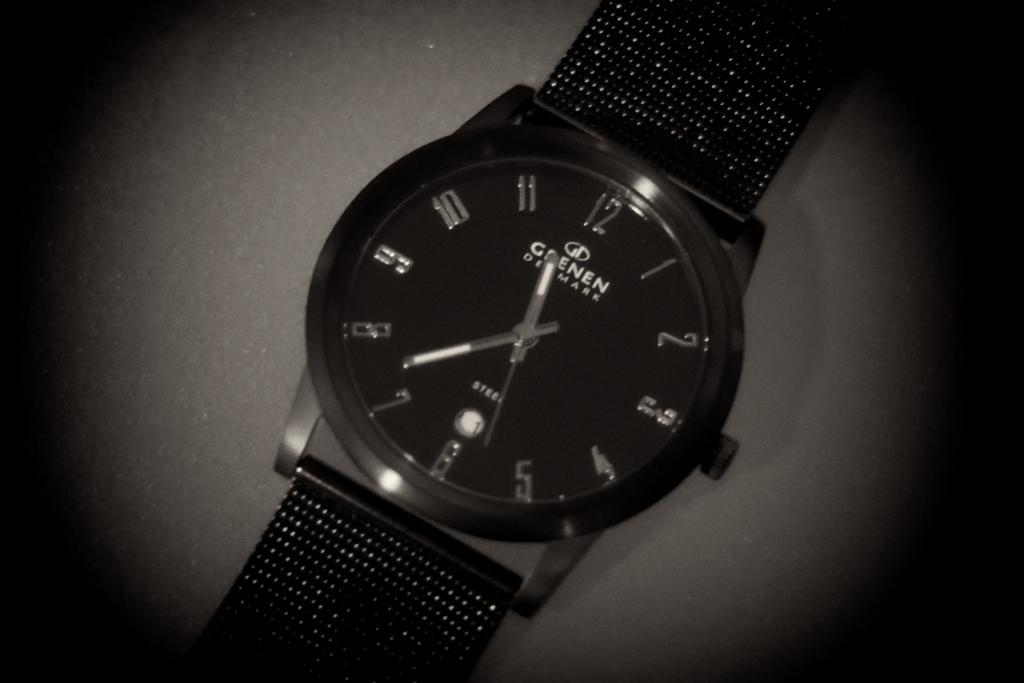Is the watch brand goenen made in denmark?
Ensure brevity in your answer.  Yes. 